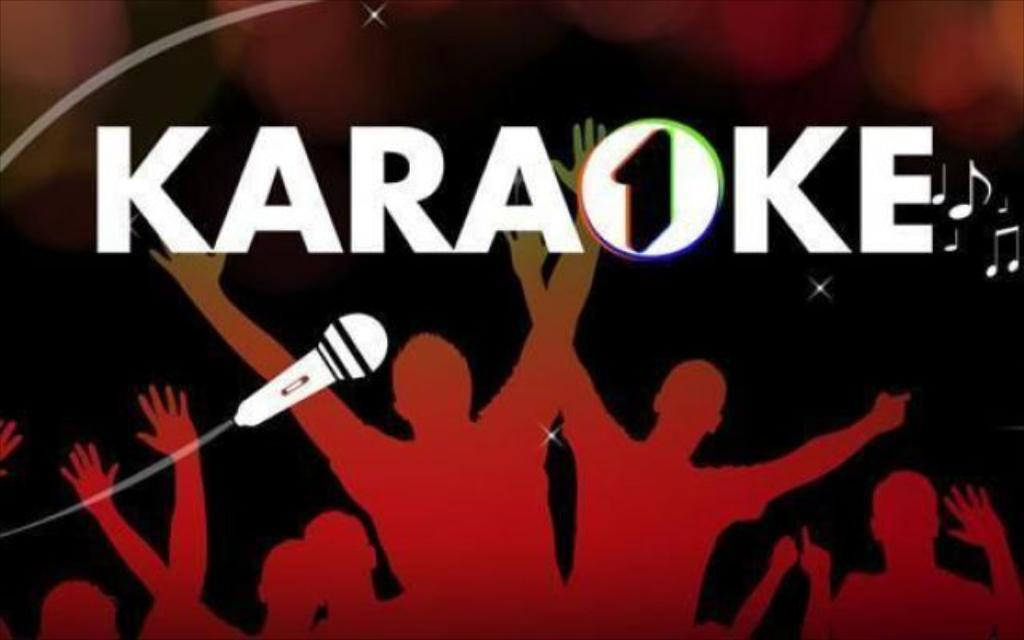<image>
Summarize the visual content of the image. An illustrated image type advertisement that says, Karaoke. 